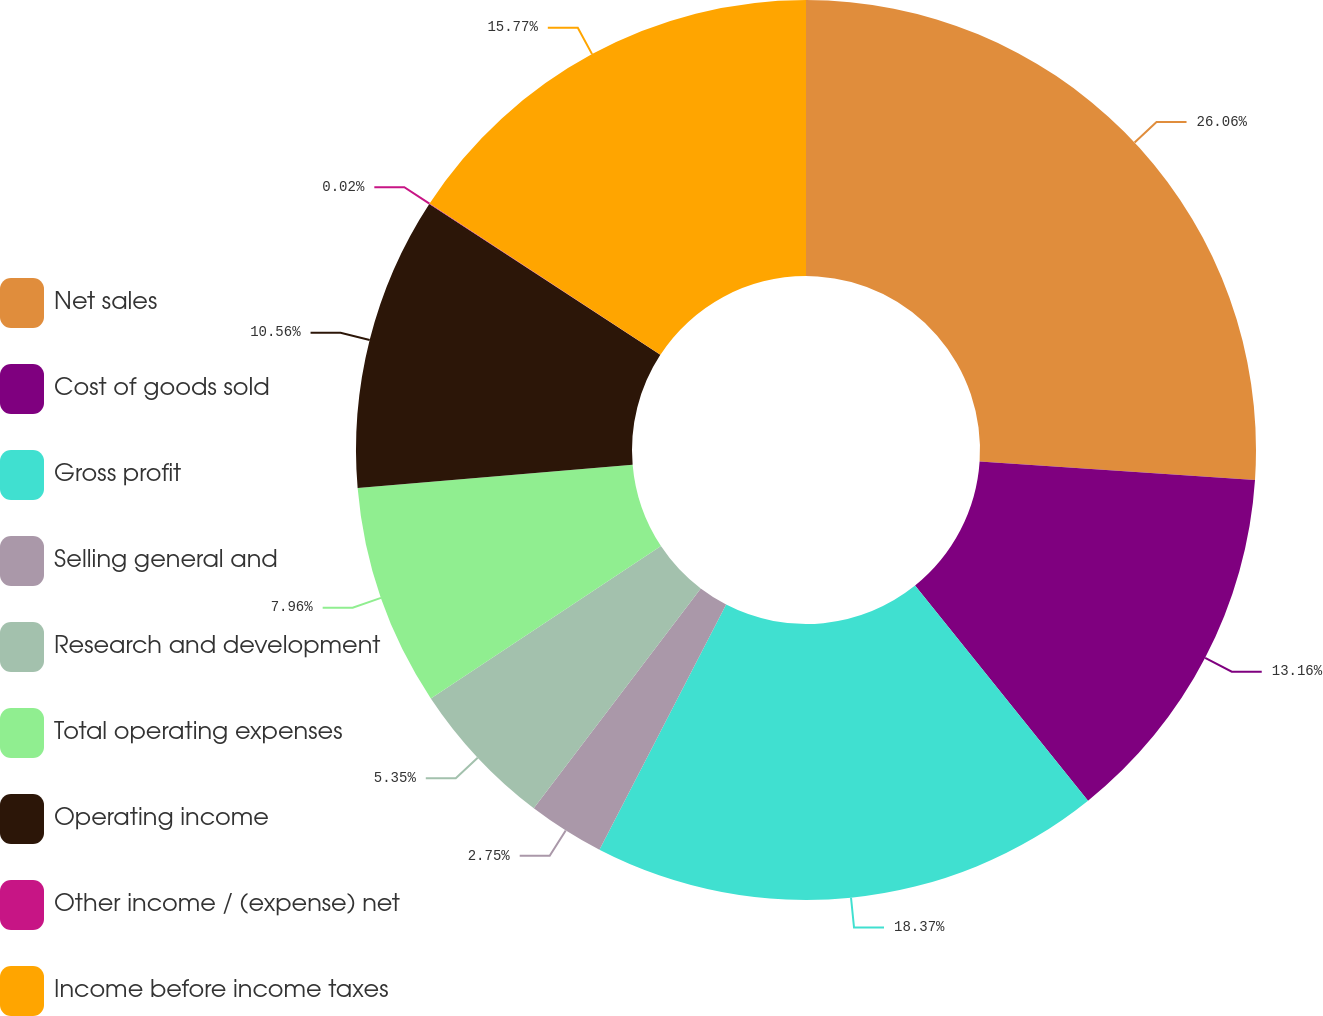Convert chart to OTSL. <chart><loc_0><loc_0><loc_500><loc_500><pie_chart><fcel>Net sales<fcel>Cost of goods sold<fcel>Gross profit<fcel>Selling general and<fcel>Research and development<fcel>Total operating expenses<fcel>Operating income<fcel>Other income / (expense) net<fcel>Income before income taxes<nl><fcel>26.06%<fcel>13.16%<fcel>18.37%<fcel>2.75%<fcel>5.35%<fcel>7.96%<fcel>10.56%<fcel>0.02%<fcel>15.77%<nl></chart> 